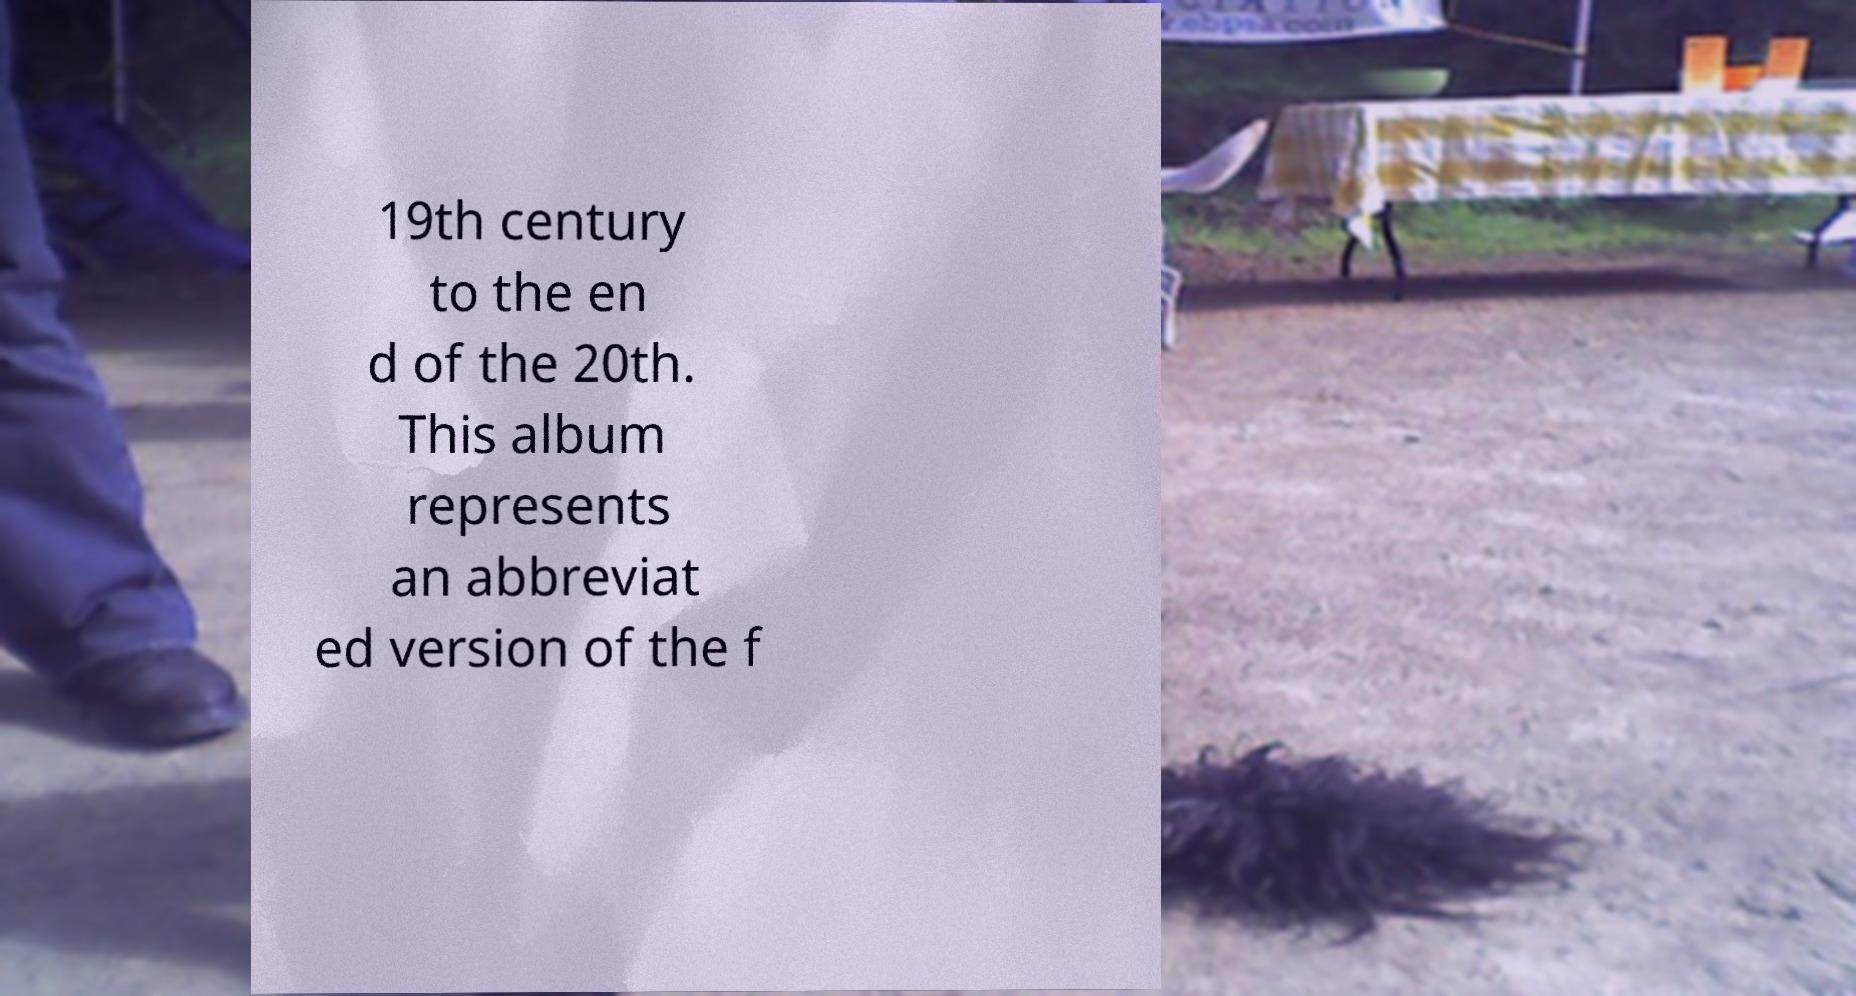I need the written content from this picture converted into text. Can you do that? 19th century to the en d of the 20th. This album represents an abbreviat ed version of the f 